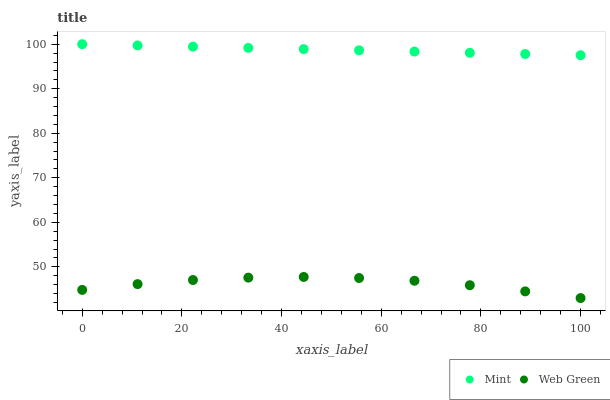Does Web Green have the minimum area under the curve?
Answer yes or no. Yes. Does Mint have the maximum area under the curve?
Answer yes or no. Yes. Does Web Green have the maximum area under the curve?
Answer yes or no. No. Is Mint the smoothest?
Answer yes or no. Yes. Is Web Green the roughest?
Answer yes or no. Yes. Is Web Green the smoothest?
Answer yes or no. No. Does Web Green have the lowest value?
Answer yes or no. Yes. Does Mint have the highest value?
Answer yes or no. Yes. Does Web Green have the highest value?
Answer yes or no. No. Is Web Green less than Mint?
Answer yes or no. Yes. Is Mint greater than Web Green?
Answer yes or no. Yes. Does Web Green intersect Mint?
Answer yes or no. No. 